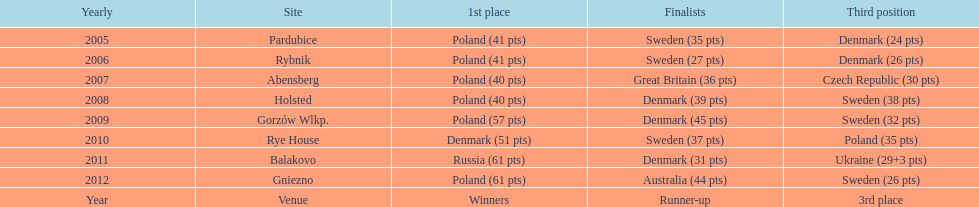Can you give me this table as a dict? {'header': ['Yearly', 'Site', '1st place', 'Finalists', 'Third position'], 'rows': [['2005', 'Pardubice', 'Poland (41 pts)', 'Sweden (35 pts)', 'Denmark (24 pts)'], ['2006', 'Rybnik', 'Poland (41 pts)', 'Sweden (27 pts)', 'Denmark (26 pts)'], ['2007', 'Abensberg', 'Poland (40 pts)', 'Great Britain (36 pts)', 'Czech Republic (30 pts)'], ['2008', 'Holsted', 'Poland (40 pts)', 'Denmark (39 pts)', 'Sweden (38 pts)'], ['2009', 'Gorzów Wlkp.', 'Poland (57 pts)', 'Denmark (45 pts)', 'Sweden (32 pts)'], ['2010', 'Rye House', 'Denmark (51 pts)', 'Sweden (37 pts)', 'Poland (35 pts)'], ['2011', 'Balakovo', 'Russia (61 pts)', 'Denmark (31 pts)', 'Ukraine (29+3 pts)'], ['2012', 'Gniezno', 'Poland (61 pts)', 'Australia (44 pts)', 'Sweden (26 pts)'], ['Year', 'Venue', 'Winners', 'Runner-up', '3rd place']]} When was the first year that poland did not place in the top three positions of the team speedway junior world championship? 2011. 